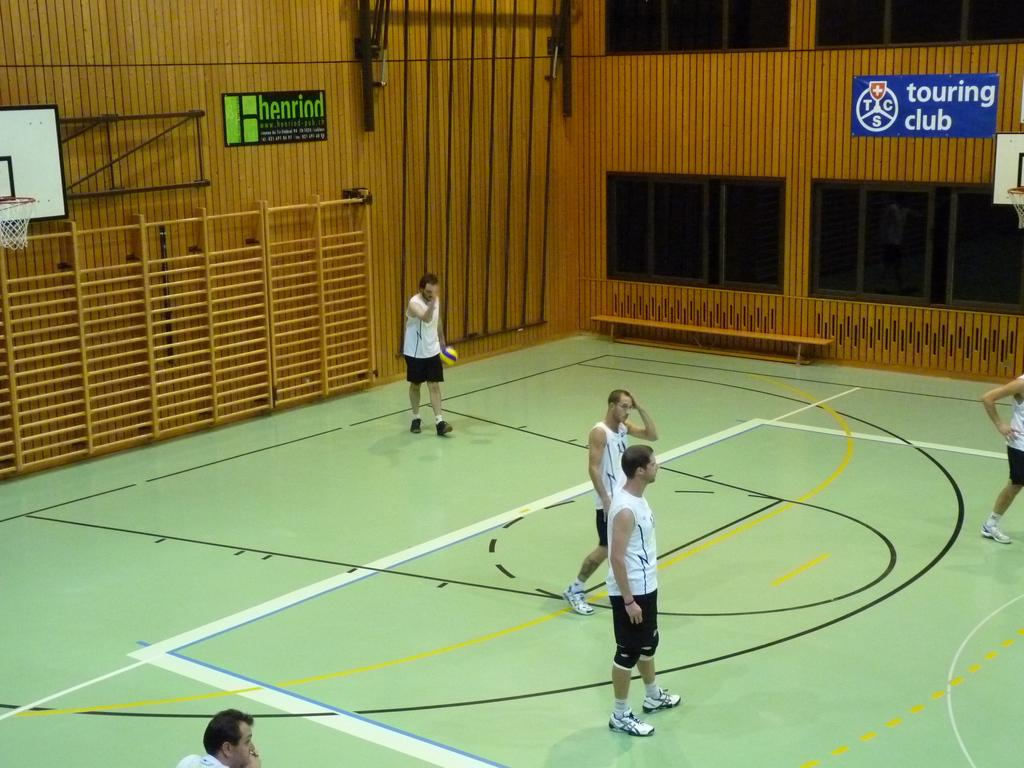Provide a one-sentence caption for the provided image. Several men are standing on a green, basketball court with posters on the wall around them advertising a touring club and henriod. 